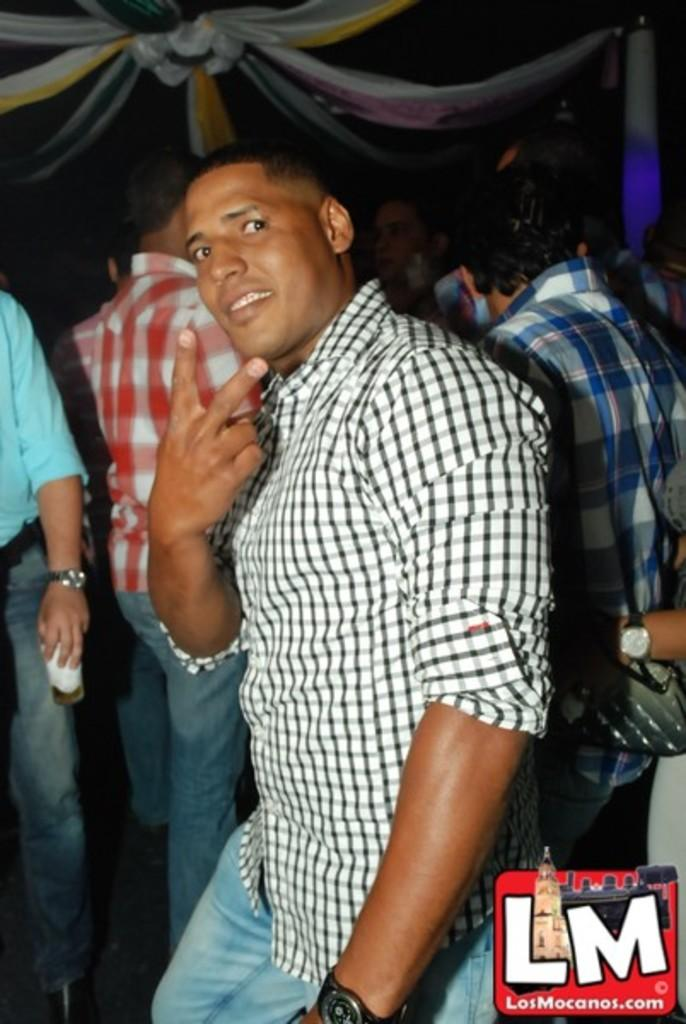What are the people in the image doing? There are people standing in the image. Can you describe the action of one of the people? There is a person holding a glass in the image. What can be seen on the roof in the image? The roof is decorated with a cloth. What type of force is being applied to the grape in the image? There is no grape present in the image, so it is not possible to determine if any force is being applied to it. 